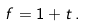<formula> <loc_0><loc_0><loc_500><loc_500>f = 1 + t \, .</formula> 